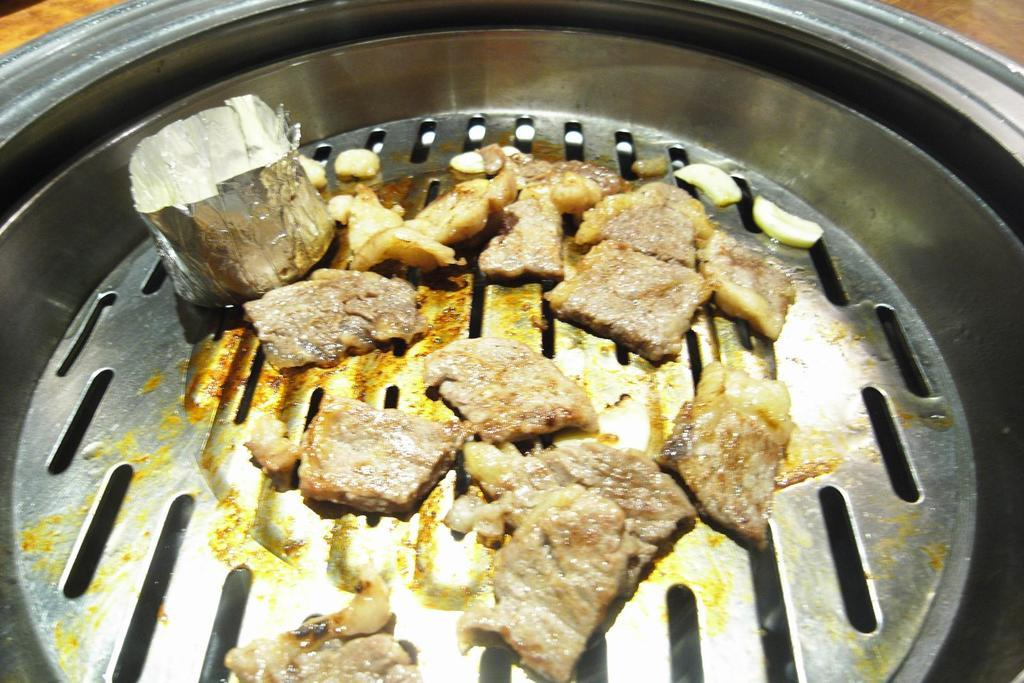What object in the image can be used for eating or cooking? There is an utensil in the image that can be used for eating or cooking. What is on the utensil? There is food on the utensil. What is the color of the food on the utensil? The food is brown in color. What is the material of the foil paper in the image? The foil paper in the image is made of aluminum. How many brothers are visible in the image? There are no brothers present in the image. What color is the breath of the person in the image? There is no person or breath visible in the image. 